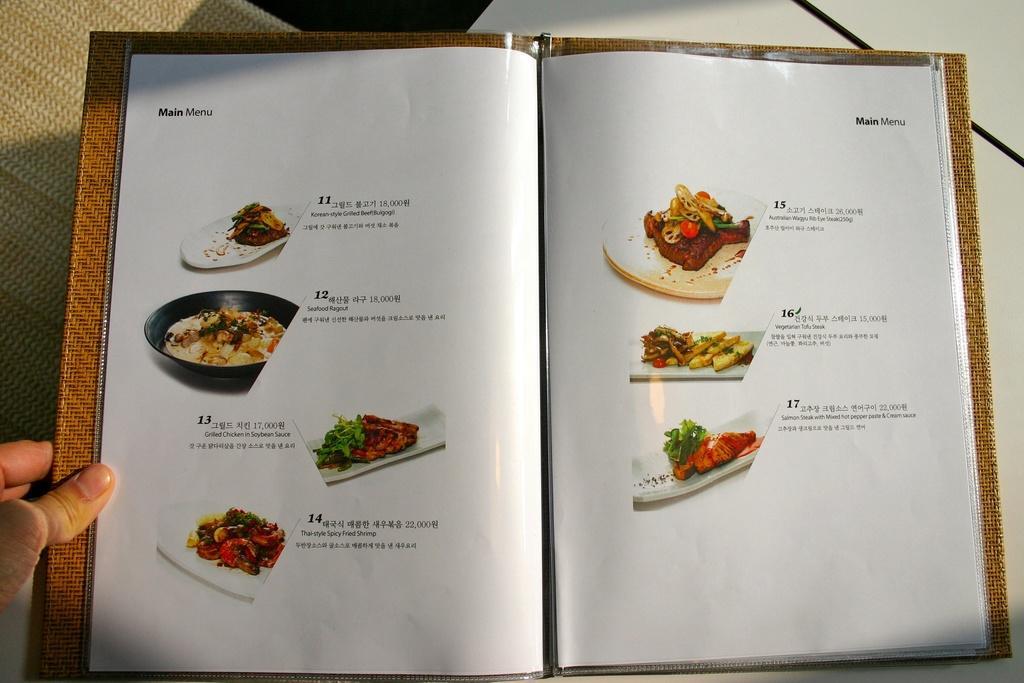Describe this image in one or two sentences. Here in this picture we can see a menu book present on a table and in that we can see pictures of food items with description and on the left side we can see a person's hand. 